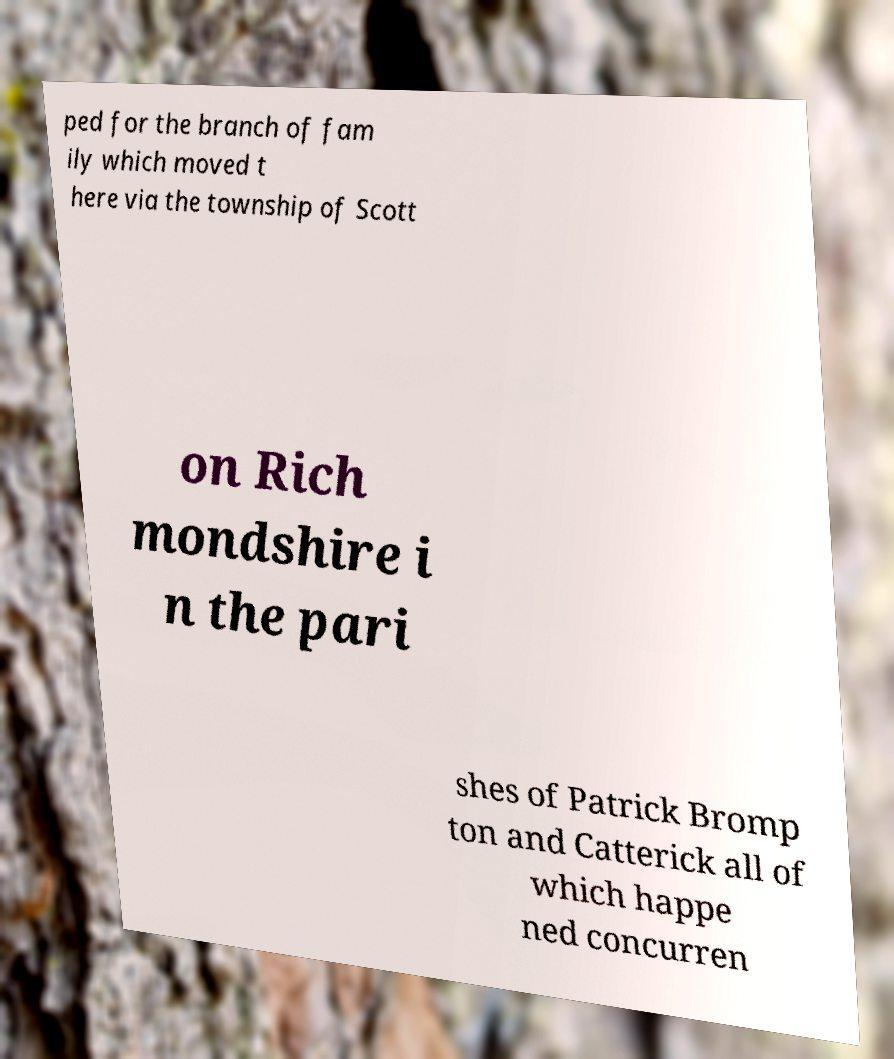Could you assist in decoding the text presented in this image and type it out clearly? ped for the branch of fam ily which moved t here via the township of Scott on Rich mondshire i n the pari shes of Patrick Bromp ton and Catterick all of which happe ned concurren 